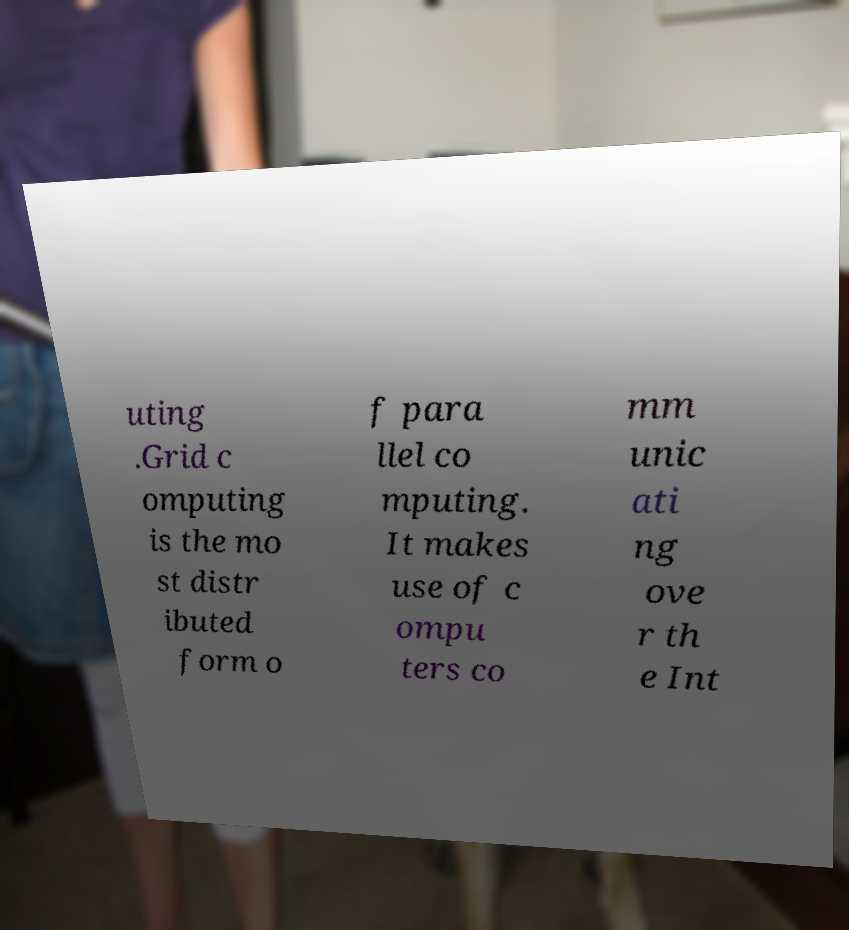For documentation purposes, I need the text within this image transcribed. Could you provide that? uting .Grid c omputing is the mo st distr ibuted form o f para llel co mputing. It makes use of c ompu ters co mm unic ati ng ove r th e Int 